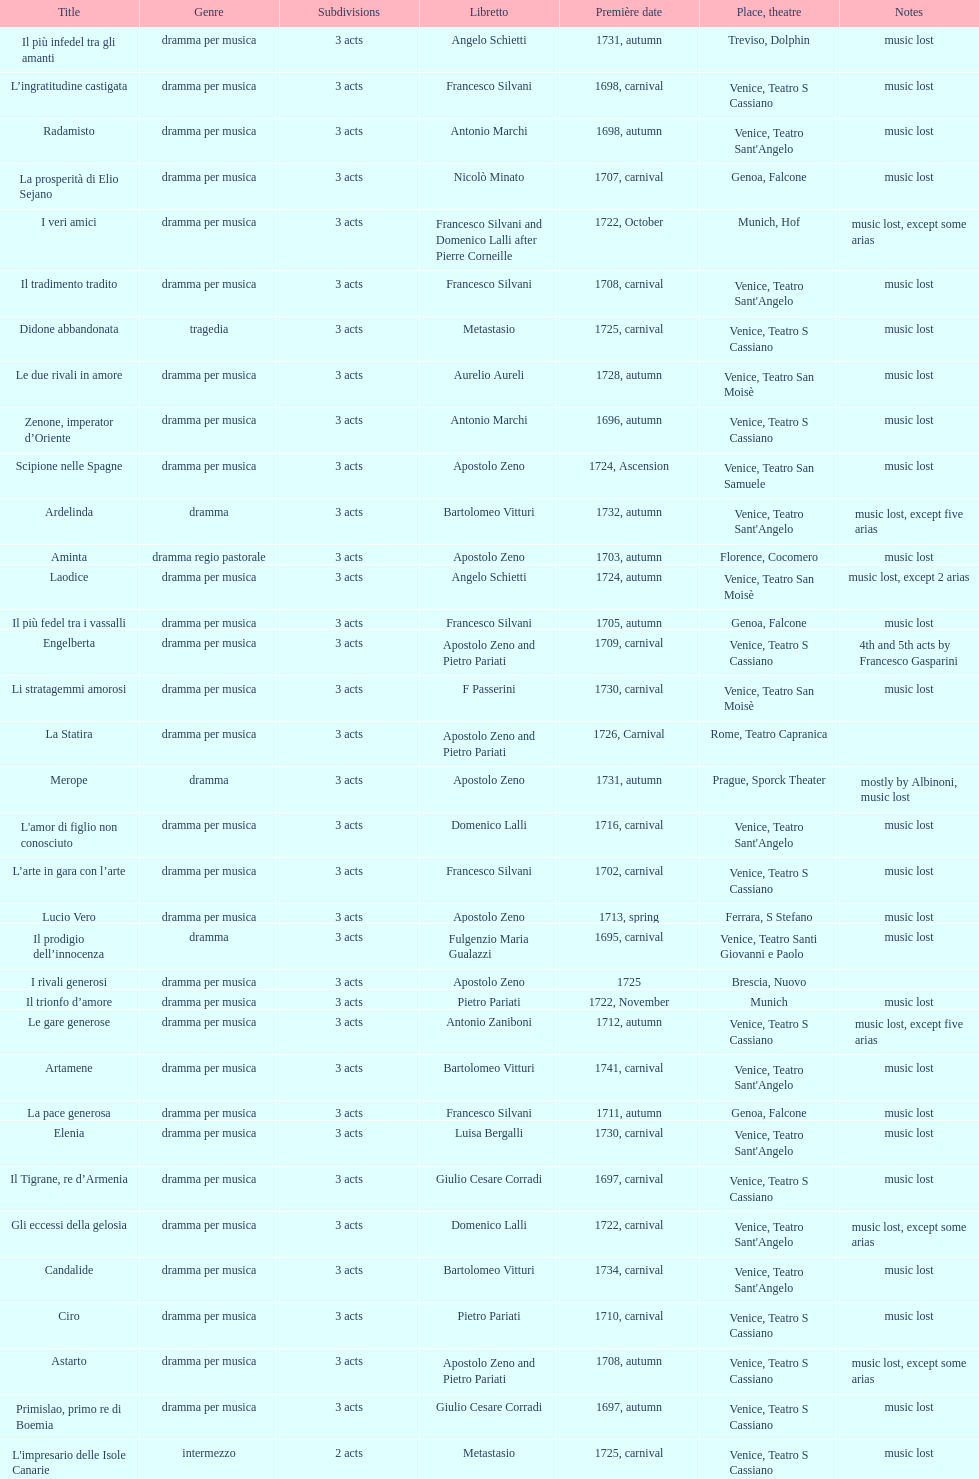What is next after ardelinda? Candalide. 